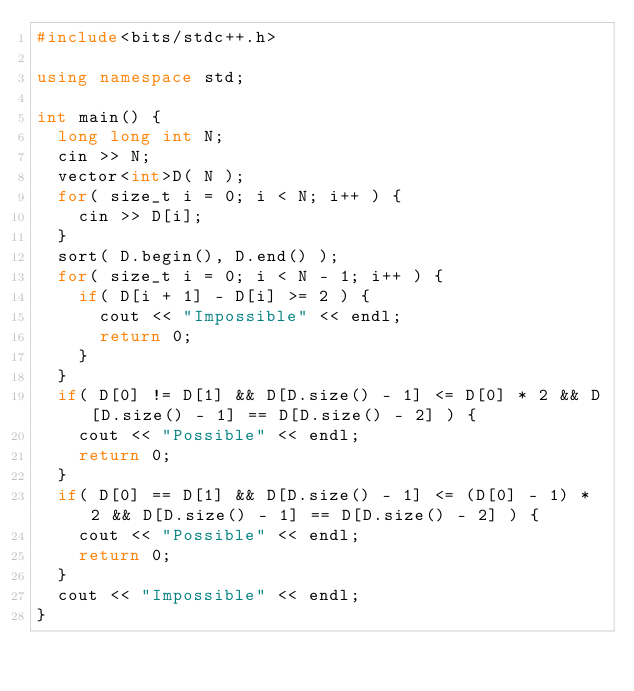<code> <loc_0><loc_0><loc_500><loc_500><_C++_>#include<bits/stdc++.h>

using namespace std;

int main() {
	long long int N;
	cin >> N;
	vector<int>D( N );
	for( size_t i = 0; i < N; i++ ) {
		cin >> D[i];
	}
	sort( D.begin(), D.end() );
	for( size_t i = 0; i < N - 1; i++ ) {
		if( D[i + 1] - D[i] >= 2 ) {
			cout << "Impossible" << endl;
			return 0;
		}
	}
	if( D[0] != D[1] && D[D.size() - 1] <= D[0] * 2 && D[D.size() - 1] == D[D.size() - 2] ) {
		cout << "Possible" << endl;
		return 0;
	}
	if( D[0] == D[1] && D[D.size() - 1] <= (D[0] - 1) * 2 && D[D.size() - 1] == D[D.size() - 2] ) {
		cout << "Possible" << endl;
		return 0;
	}
	cout << "Impossible" << endl;
}</code> 